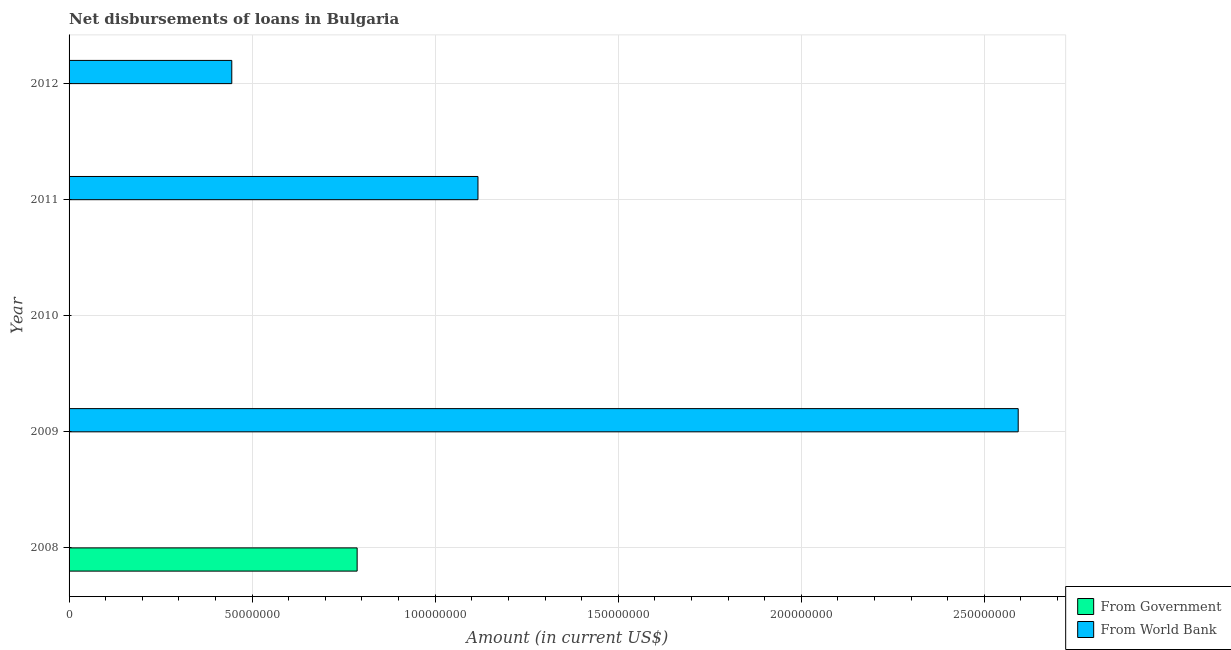How many different coloured bars are there?
Give a very brief answer. 2. Are the number of bars per tick equal to the number of legend labels?
Keep it short and to the point. No. Are the number of bars on each tick of the Y-axis equal?
Ensure brevity in your answer.  No. How many bars are there on the 3rd tick from the top?
Give a very brief answer. 0. In how many cases, is the number of bars for a given year not equal to the number of legend labels?
Provide a succinct answer. 5. Across all years, what is the maximum net disbursements of loan from world bank?
Your response must be concise. 2.59e+08. What is the total net disbursements of loan from government in the graph?
Make the answer very short. 7.87e+07. What is the difference between the net disbursements of loan from world bank in 2009 and that in 2012?
Ensure brevity in your answer.  2.15e+08. What is the average net disbursements of loan from world bank per year?
Provide a succinct answer. 8.31e+07. In how many years, is the net disbursements of loan from government greater than 200000000 US$?
Provide a succinct answer. 0. What is the difference between the highest and the second highest net disbursements of loan from world bank?
Keep it short and to the point. 1.48e+08. What is the difference between the highest and the lowest net disbursements of loan from world bank?
Your answer should be compact. 2.59e+08. In how many years, is the net disbursements of loan from world bank greater than the average net disbursements of loan from world bank taken over all years?
Offer a terse response. 2. Are all the bars in the graph horizontal?
Your answer should be compact. Yes. How many years are there in the graph?
Your answer should be compact. 5. What is the difference between two consecutive major ticks on the X-axis?
Offer a terse response. 5.00e+07. Are the values on the major ticks of X-axis written in scientific E-notation?
Ensure brevity in your answer.  No. Does the graph contain any zero values?
Make the answer very short. Yes. Does the graph contain grids?
Offer a terse response. Yes. Where does the legend appear in the graph?
Keep it short and to the point. Bottom right. How many legend labels are there?
Your answer should be compact. 2. What is the title of the graph?
Ensure brevity in your answer.  Net disbursements of loans in Bulgaria. What is the label or title of the X-axis?
Ensure brevity in your answer.  Amount (in current US$). What is the label or title of the Y-axis?
Provide a short and direct response. Year. What is the Amount (in current US$) in From Government in 2008?
Keep it short and to the point. 7.87e+07. What is the Amount (in current US$) in From World Bank in 2008?
Keep it short and to the point. 0. What is the Amount (in current US$) of From World Bank in 2009?
Offer a terse response. 2.59e+08. What is the Amount (in current US$) in From World Bank in 2010?
Your answer should be very brief. 0. What is the Amount (in current US$) in From World Bank in 2011?
Provide a succinct answer. 1.12e+08. What is the Amount (in current US$) in From World Bank in 2012?
Your answer should be compact. 4.44e+07. Across all years, what is the maximum Amount (in current US$) of From Government?
Offer a very short reply. 7.87e+07. Across all years, what is the maximum Amount (in current US$) in From World Bank?
Your answer should be very brief. 2.59e+08. Across all years, what is the minimum Amount (in current US$) of From Government?
Offer a very short reply. 0. What is the total Amount (in current US$) of From Government in the graph?
Give a very brief answer. 7.87e+07. What is the total Amount (in current US$) in From World Bank in the graph?
Keep it short and to the point. 4.15e+08. What is the difference between the Amount (in current US$) of From World Bank in 2009 and that in 2011?
Your answer should be compact. 1.48e+08. What is the difference between the Amount (in current US$) in From World Bank in 2009 and that in 2012?
Ensure brevity in your answer.  2.15e+08. What is the difference between the Amount (in current US$) in From World Bank in 2011 and that in 2012?
Offer a very short reply. 6.72e+07. What is the difference between the Amount (in current US$) in From Government in 2008 and the Amount (in current US$) in From World Bank in 2009?
Provide a succinct answer. -1.81e+08. What is the difference between the Amount (in current US$) of From Government in 2008 and the Amount (in current US$) of From World Bank in 2011?
Ensure brevity in your answer.  -3.30e+07. What is the difference between the Amount (in current US$) in From Government in 2008 and the Amount (in current US$) in From World Bank in 2012?
Provide a succinct answer. 3.42e+07. What is the average Amount (in current US$) in From Government per year?
Give a very brief answer. 1.57e+07. What is the average Amount (in current US$) of From World Bank per year?
Make the answer very short. 8.31e+07. What is the ratio of the Amount (in current US$) in From World Bank in 2009 to that in 2011?
Offer a very short reply. 2.32. What is the ratio of the Amount (in current US$) in From World Bank in 2009 to that in 2012?
Offer a very short reply. 5.83. What is the ratio of the Amount (in current US$) of From World Bank in 2011 to that in 2012?
Your response must be concise. 2.51. What is the difference between the highest and the second highest Amount (in current US$) in From World Bank?
Keep it short and to the point. 1.48e+08. What is the difference between the highest and the lowest Amount (in current US$) in From Government?
Provide a succinct answer. 7.87e+07. What is the difference between the highest and the lowest Amount (in current US$) of From World Bank?
Offer a very short reply. 2.59e+08. 